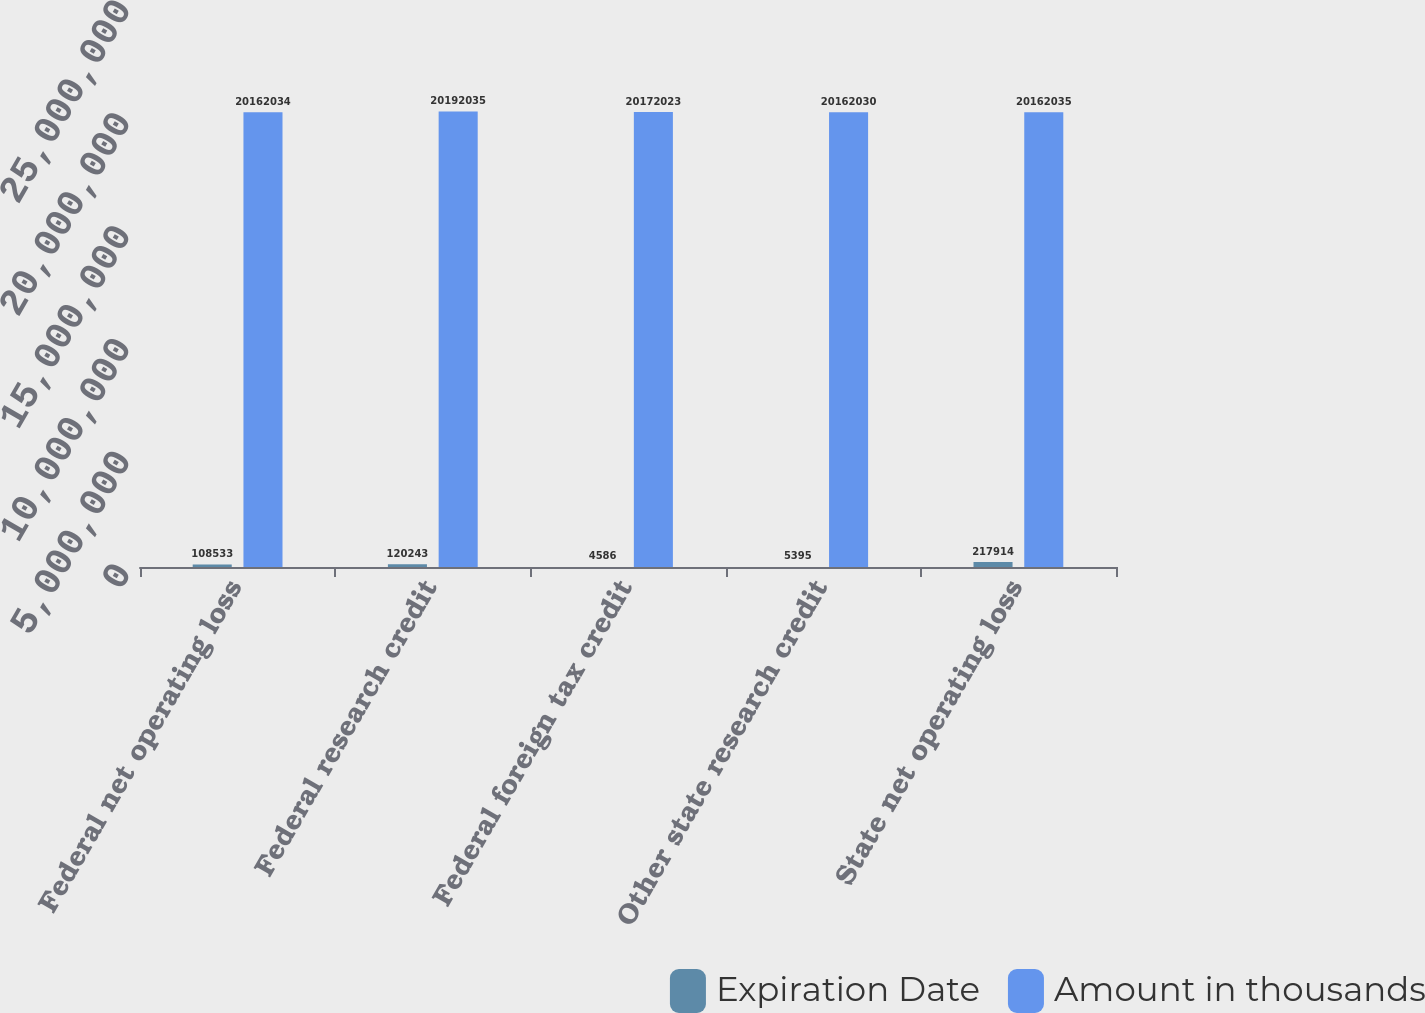Convert chart to OTSL. <chart><loc_0><loc_0><loc_500><loc_500><stacked_bar_chart><ecel><fcel>Federal net operating loss<fcel>Federal research credit<fcel>Federal foreign tax credit<fcel>Other state research credit<fcel>State net operating loss<nl><fcel>Expiration Date<fcel>108533<fcel>120243<fcel>4586<fcel>5395<fcel>217914<nl><fcel>Amount in thousands<fcel>2.0162e+07<fcel>2.0192e+07<fcel>2.0172e+07<fcel>2.0162e+07<fcel>2.0162e+07<nl></chart> 